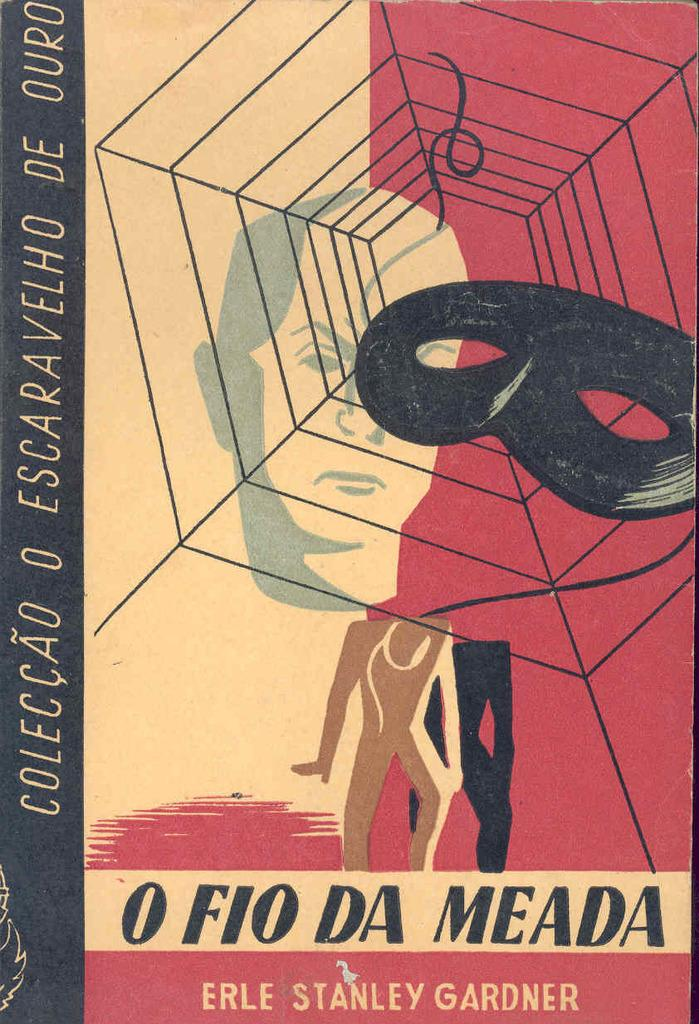What object is visible in the image? There is a magazine in the image. What can be found inside the magazine? There are figures and text in the magazine. What type of alarm can be heard in the image? There is no alarm present in the image; it is a magazine with figures and text. How many boats are visible in the image? There are no boats present in the image; it is a magazine with figures and text. 